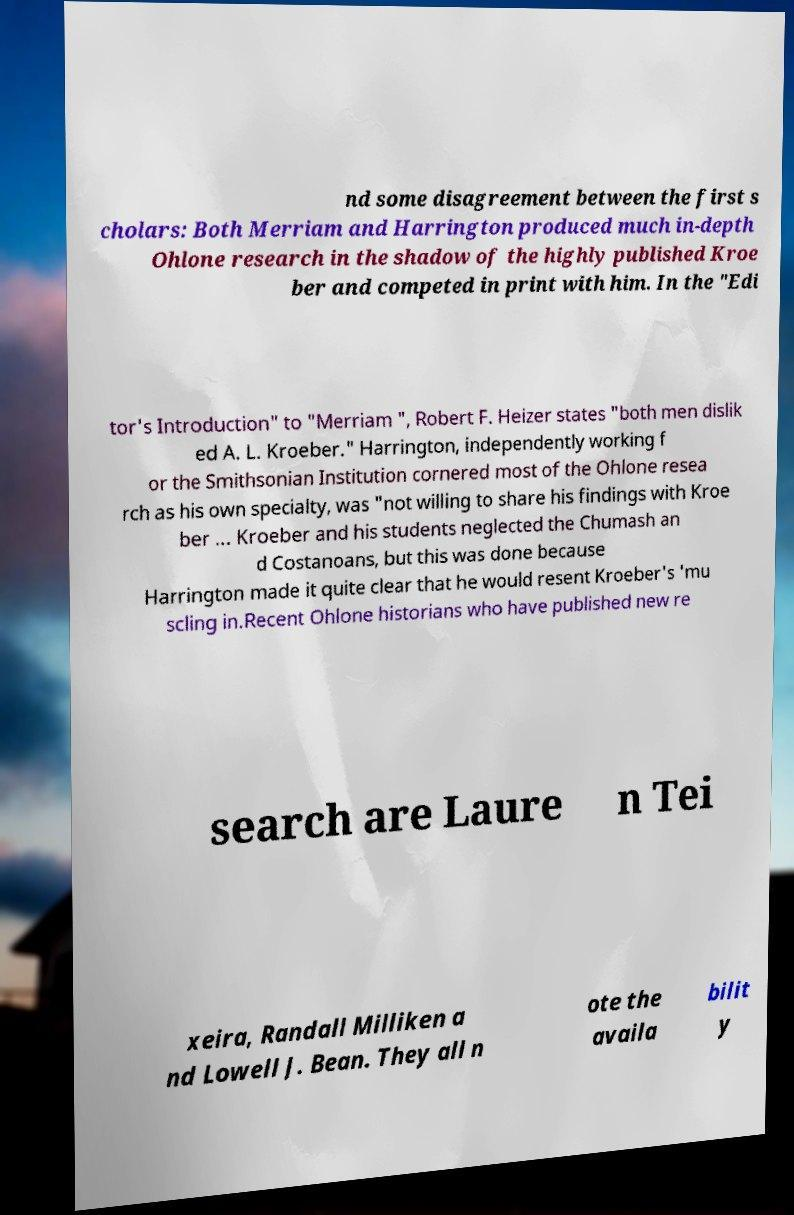I need the written content from this picture converted into text. Can you do that? nd some disagreement between the first s cholars: Both Merriam and Harrington produced much in-depth Ohlone research in the shadow of the highly published Kroe ber and competed in print with him. In the "Edi tor's Introduction" to "Merriam ", Robert F. Heizer states "both men dislik ed A. L. Kroeber." Harrington, independently working f or the Smithsonian Institution cornered most of the Ohlone resea rch as his own specialty, was "not willing to share his findings with Kroe ber ... Kroeber and his students neglected the Chumash an d Costanoans, but this was done because Harrington made it quite clear that he would resent Kroeber's 'mu scling in.Recent Ohlone historians who have published new re search are Laure n Tei xeira, Randall Milliken a nd Lowell J. Bean. They all n ote the availa bilit y 